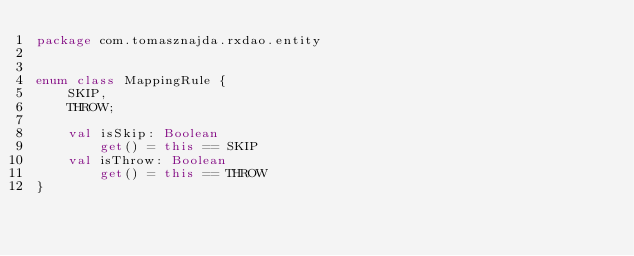Convert code to text. <code><loc_0><loc_0><loc_500><loc_500><_Kotlin_>package com.tomasznajda.rxdao.entity


enum class MappingRule {
    SKIP,
    THROW;

    val isSkip: Boolean
        get() = this == SKIP
    val isThrow: Boolean
        get() = this == THROW
}</code> 